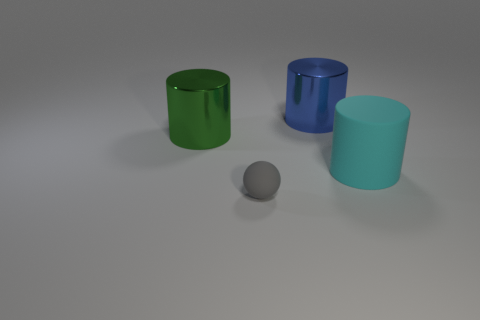Subtract all big green cylinders. How many cylinders are left? 2 Add 3 tiny red cylinders. How many objects exist? 7 Subtract all balls. How many objects are left? 3 Subtract 0 purple cylinders. How many objects are left? 4 Subtract all large blue cylinders. Subtract all large purple rubber spheres. How many objects are left? 3 Add 2 big things. How many big things are left? 5 Add 1 big matte blocks. How many big matte blocks exist? 1 